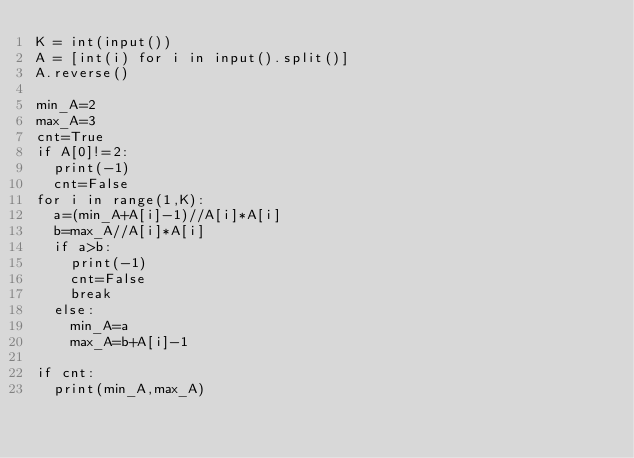Convert code to text. <code><loc_0><loc_0><loc_500><loc_500><_Python_>K = int(input())
A = [int(i) for i in input().split()]
A.reverse()

min_A=2
max_A=3
cnt=True
if A[0]!=2:
  print(-1)
  cnt=False
for i in range(1,K):
  a=(min_A+A[i]-1)//A[i]*A[i]
  b=max_A//A[i]*A[i]
  if a>b:
    print(-1)
    cnt=False
    break
  else:
    min_A=a
    max_A=b+A[i]-1

if cnt:
  print(min_A,max_A)
</code> 